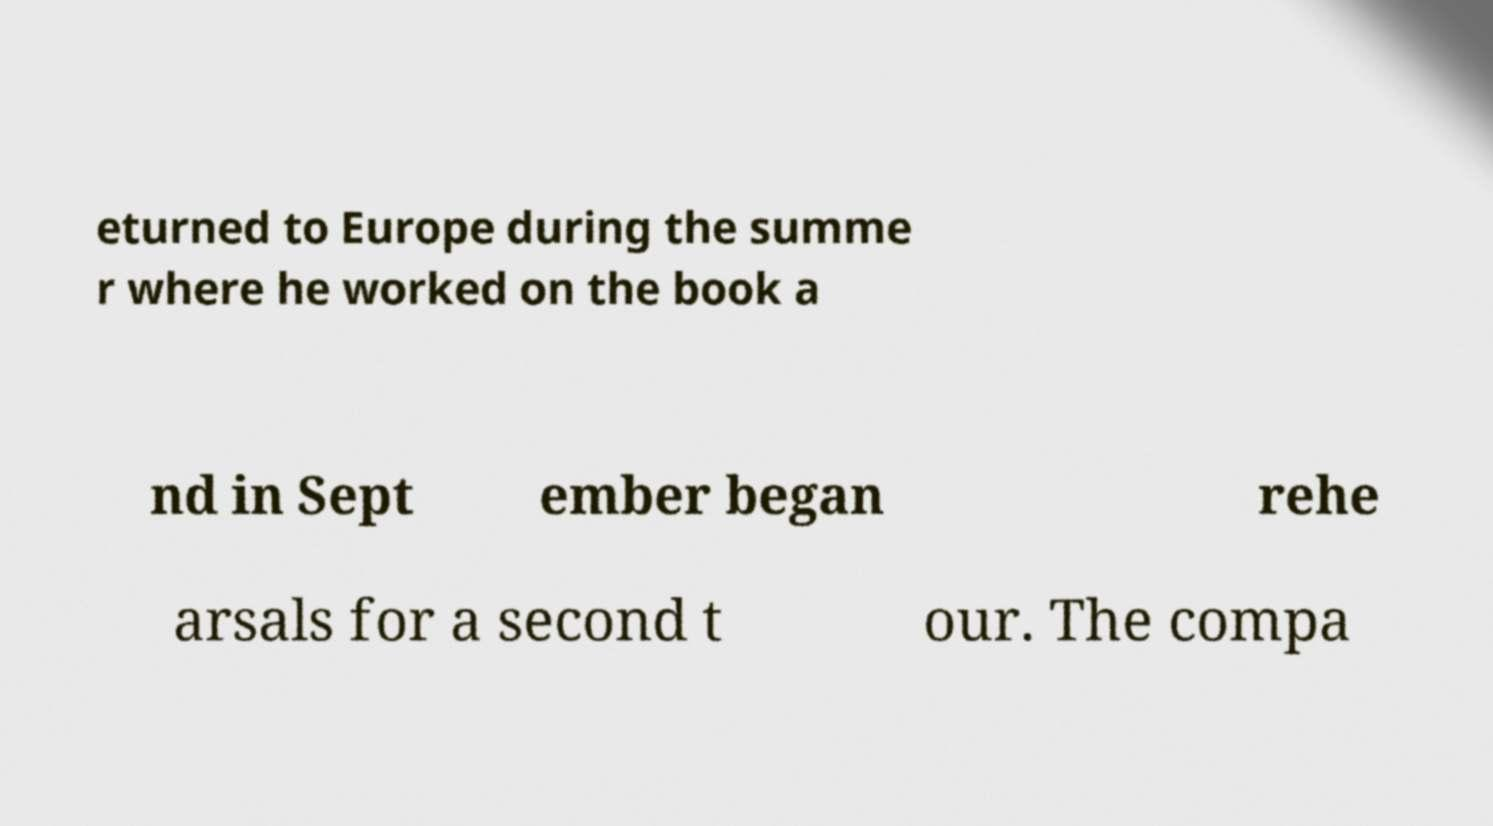Please identify and transcribe the text found in this image. eturned to Europe during the summe r where he worked on the book a nd in Sept ember began rehe arsals for a second t our. The compa 